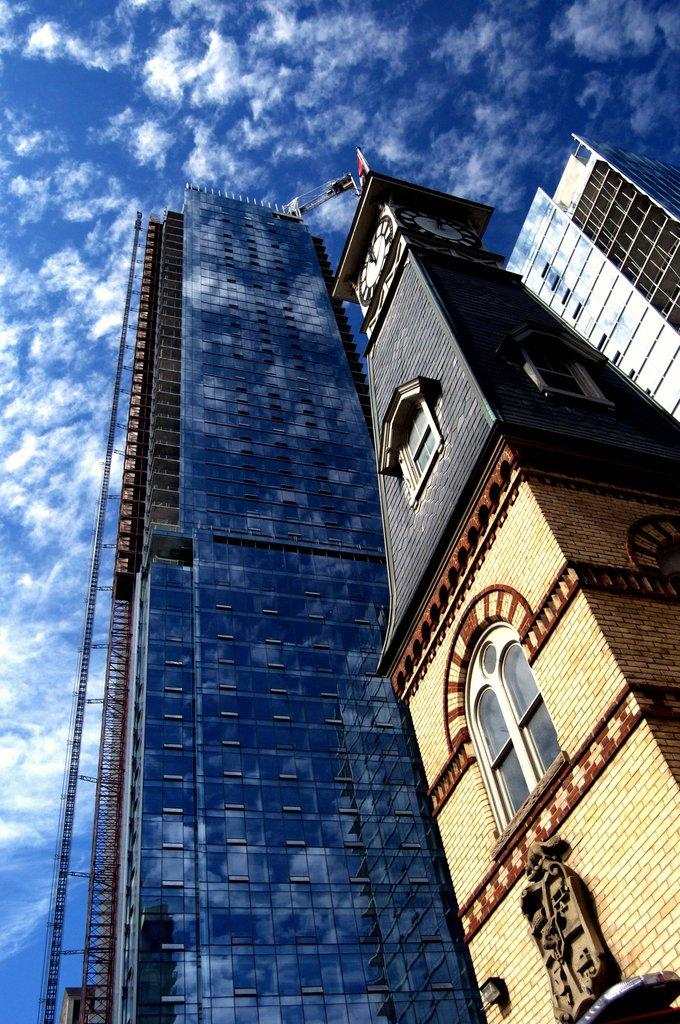What structures are visible in the image? There are buildings in the image. What can be seen in the background of the image? The sky is visible in the background of the image. What is the condition of the sky in the image? Clouds are present in the sky. What type of cloth is being used to jump over the buildings in the image? There is no cloth or jumping activity present in the image; it features buildings and a sky with clouds. 